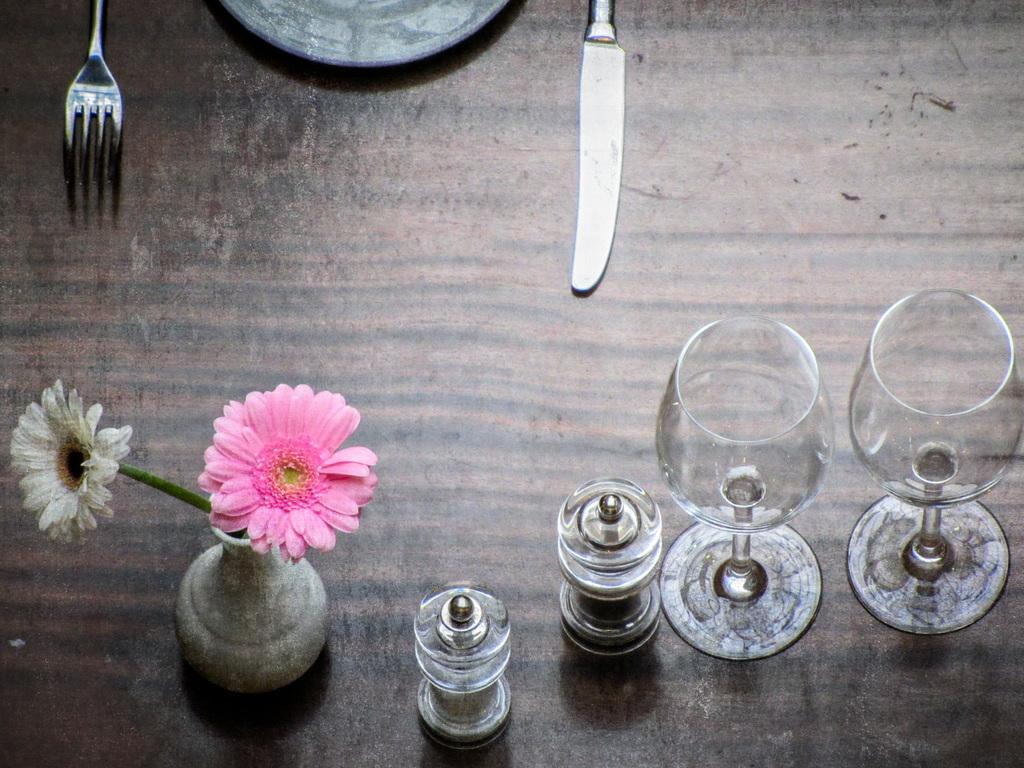What type of tableware can be seen in the image? There are glasses, a fork, a knife, and a plate in the image. What is the decorative item in the image? There are flowers in a vase in the image. Where are these items located? They are on a wooden platform in the image. Reasoning: Let' Let's think step by step in order to produce the conversation. We start by identifying the main tableware items in the image, which are glasses, a fork, a knife, and a plate. Then, we mention the decorative item, which is the flowers in a vase. Finally, we describe the location of these items, which is on a wooden platform. Absurd Question/Answer: Can you see the father pitching a tent in the image? There is no father or tent present in the image. What is the wooden platform used for in the image? The wooden platform is used to hold the tableware items and the vase with flowers, but there is no mention of any specific activity or purpose related to smashing in the image. Can you see the father pitching a tent in the image? There is no father or tent present in the image. What is the wooden platform used for in the image? The wooden platform is used to hold the tableware items and the vase with flowers, but there is no mention of any specific activity or purpose related to smashing in the image. 